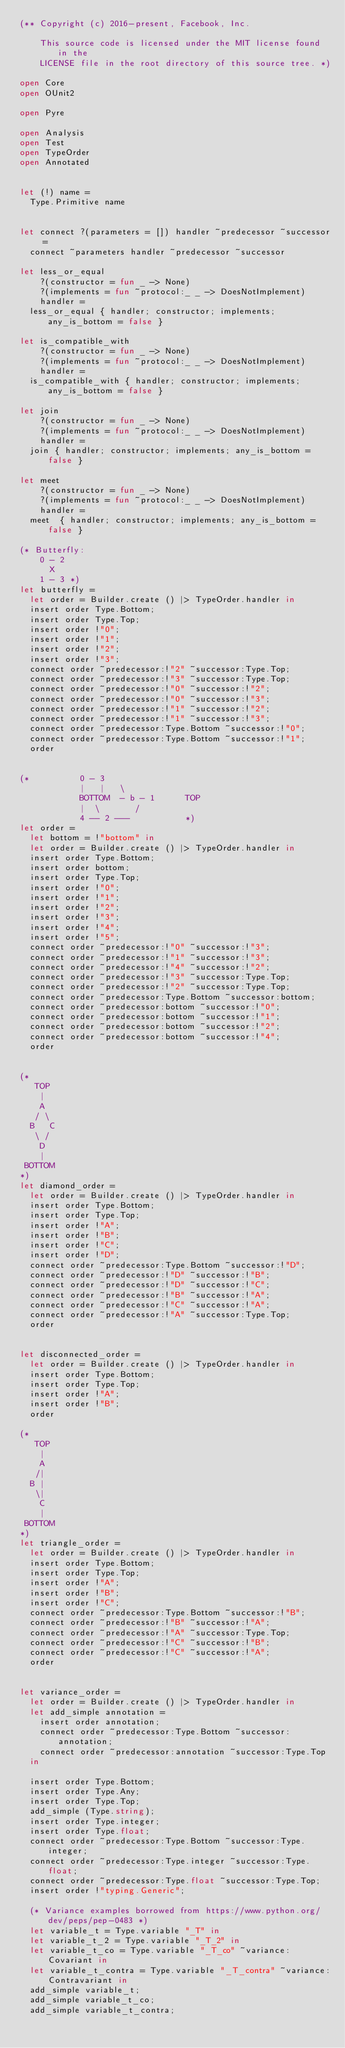<code> <loc_0><loc_0><loc_500><loc_500><_OCaml_>(** Copyright (c) 2016-present, Facebook, Inc.

    This source code is licensed under the MIT license found in the
    LICENSE file in the root directory of this source tree. *)

open Core
open OUnit2

open Pyre

open Analysis
open Test
open TypeOrder
open Annotated


let (!) name =
  Type.Primitive name


let connect ?(parameters = []) handler ~predecessor ~successor =
  connect ~parameters handler ~predecessor ~successor

let less_or_equal
    ?(constructor = fun _ -> None)
    ?(implements = fun ~protocol:_ _ -> DoesNotImplement)
    handler =
  less_or_equal { handler; constructor; implements; any_is_bottom = false }

let is_compatible_with
    ?(constructor = fun _ -> None)
    ?(implements = fun ~protocol:_ _ -> DoesNotImplement)
    handler =
  is_compatible_with { handler; constructor; implements; any_is_bottom = false }

let join
    ?(constructor = fun _ -> None)
    ?(implements = fun ~protocol:_ _ -> DoesNotImplement)
    handler =
  join { handler; constructor; implements; any_is_bottom = false }

let meet
    ?(constructor = fun _ -> None)
    ?(implements = fun ~protocol:_ _ -> DoesNotImplement)
    handler =
  meet  { handler; constructor; implements; any_is_bottom = false }

(* Butterfly:
    0 - 2
      X
    1 - 3 *)
let butterfly =
  let order = Builder.create () |> TypeOrder.handler in
  insert order Type.Bottom;
  insert order Type.Top;
  insert order !"0";
  insert order !"1";
  insert order !"2";
  insert order !"3";
  connect order ~predecessor:!"2" ~successor:Type.Top;
  connect order ~predecessor:!"3" ~successor:Type.Top;
  connect order ~predecessor:!"0" ~successor:!"2";
  connect order ~predecessor:!"0" ~successor:!"3";
  connect order ~predecessor:!"1" ~successor:!"2";
  connect order ~predecessor:!"1" ~successor:!"3";
  connect order ~predecessor:Type.Bottom ~successor:!"0";
  connect order ~predecessor:Type.Bottom ~successor:!"1";
  order


(*          0 - 3
            |   |   \
            BOTTOM  - b - 1      TOP
            |  \       /
            4 -- 2 ---           *)
let order =
  let bottom = !"bottom" in
  let order = Builder.create () |> TypeOrder.handler in
  insert order Type.Bottom;
  insert order bottom;
  insert order Type.Top;
  insert order !"0";
  insert order !"1";
  insert order !"2";
  insert order !"3";
  insert order !"4";
  insert order !"5";
  connect order ~predecessor:!"0" ~successor:!"3";
  connect order ~predecessor:!"1" ~successor:!"3";
  connect order ~predecessor:!"4" ~successor:!"2";
  connect order ~predecessor:!"3" ~successor:Type.Top;
  connect order ~predecessor:!"2" ~successor:Type.Top;
  connect order ~predecessor:Type.Bottom ~successor:bottom;
  connect order ~predecessor:bottom ~successor:!"0";
  connect order ~predecessor:bottom ~successor:!"1";
  connect order ~predecessor:bottom ~successor:!"2";
  connect order ~predecessor:bottom ~successor:!"4";
  order


(*
   TOP
    |
    A
   / \
  B   C
   \ /
    D
    |
 BOTTOM
*)
let diamond_order =
  let order = Builder.create () |> TypeOrder.handler in
  insert order Type.Bottom;
  insert order Type.Top;
  insert order !"A";
  insert order !"B";
  insert order !"C";
  insert order !"D";
  connect order ~predecessor:Type.Bottom ~successor:!"D";
  connect order ~predecessor:!"D" ~successor:!"B";
  connect order ~predecessor:!"D" ~successor:!"C";
  connect order ~predecessor:!"B" ~successor:!"A";
  connect order ~predecessor:!"C" ~successor:!"A";
  connect order ~predecessor:!"A" ~successor:Type.Top;
  order


let disconnected_order =
  let order = Builder.create () |> TypeOrder.handler in
  insert order Type.Bottom;
  insert order Type.Top;
  insert order !"A";
  insert order !"B";
  order

(*
   TOP
    |
    A
   /|
  B |
   \|
    C
    |
 BOTTOM
*)
let triangle_order =
  let order = Builder.create () |> TypeOrder.handler in
  insert order Type.Bottom;
  insert order Type.Top;
  insert order !"A";
  insert order !"B";
  insert order !"C";
  connect order ~predecessor:Type.Bottom ~successor:!"B";
  connect order ~predecessor:!"B" ~successor:!"A";
  connect order ~predecessor:!"A" ~successor:Type.Top;
  connect order ~predecessor:!"C" ~successor:!"B";
  connect order ~predecessor:!"C" ~successor:!"A";
  order


let variance_order =
  let order = Builder.create () |> TypeOrder.handler in
  let add_simple annotation =
    insert order annotation;
    connect order ~predecessor:Type.Bottom ~successor:annotation;
    connect order ~predecessor:annotation ~successor:Type.Top
  in

  insert order Type.Bottom;
  insert order Type.Any;
  insert order Type.Top;
  add_simple (Type.string);
  insert order Type.integer;
  insert order Type.float;
  connect order ~predecessor:Type.Bottom ~successor:Type.integer;
  connect order ~predecessor:Type.integer ~successor:Type.float;
  connect order ~predecessor:Type.float ~successor:Type.Top;
  insert order !"typing.Generic";

  (* Variance examples borrowed from https://www.python.org/dev/peps/pep-0483 *)
  let variable_t = Type.variable "_T" in
  let variable_t_2 = Type.variable "_T_2" in
  let variable_t_co = Type.variable "_T_co" ~variance:Covariant in
  let variable_t_contra = Type.variable "_T_contra" ~variance:Contravariant in
  add_simple variable_t;
  add_simple variable_t_co;
  add_simple variable_t_contra;</code> 